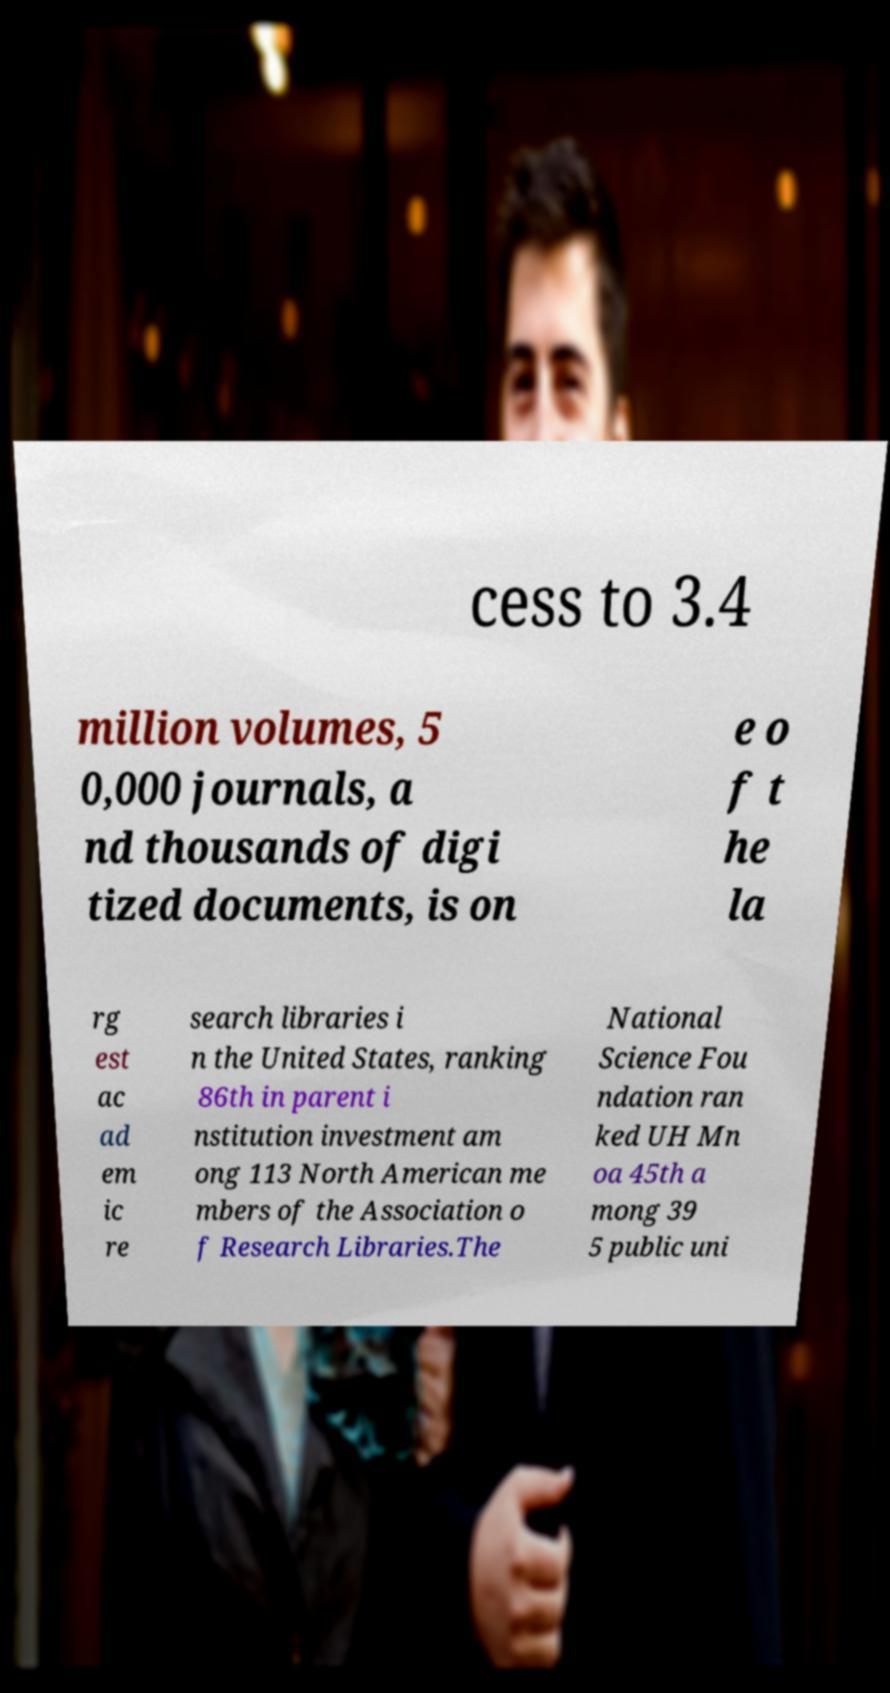Please read and relay the text visible in this image. What does it say? cess to 3.4 million volumes, 5 0,000 journals, a nd thousands of digi tized documents, is on e o f t he la rg est ac ad em ic re search libraries i n the United States, ranking 86th in parent i nstitution investment am ong 113 North American me mbers of the Association o f Research Libraries.The National Science Fou ndation ran ked UH Mn oa 45th a mong 39 5 public uni 